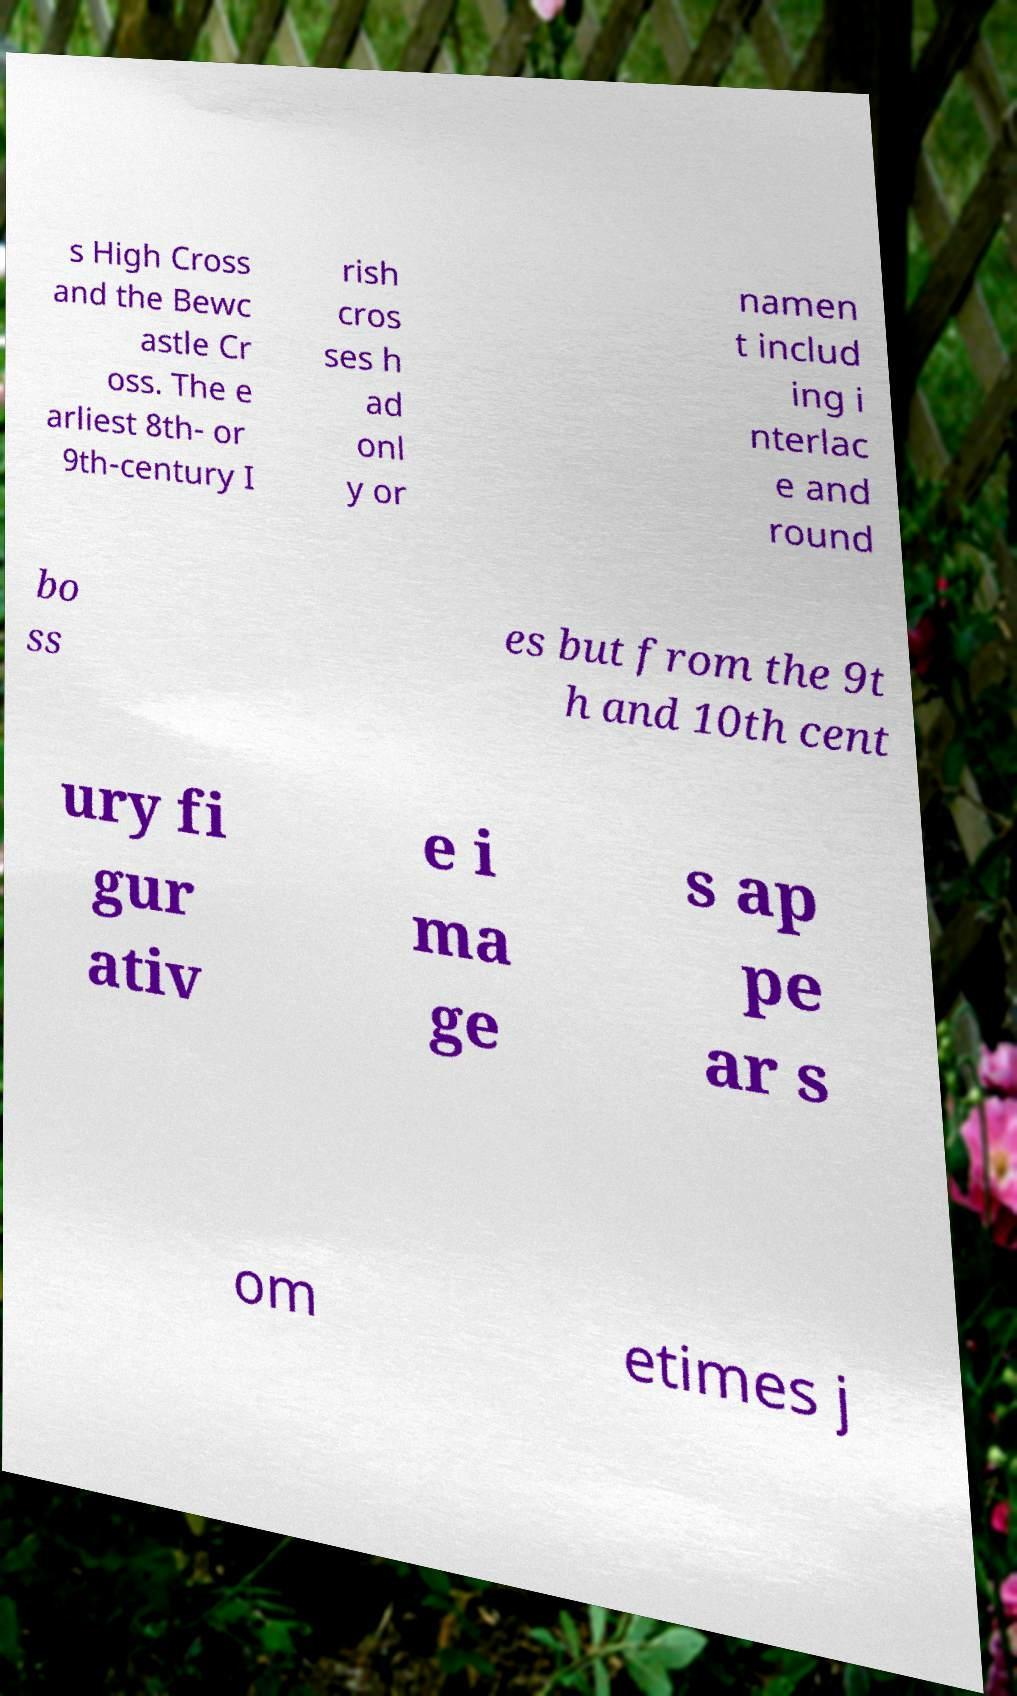Can you accurately transcribe the text from the provided image for me? s High Cross and the Bewc astle Cr oss. The e arliest 8th- or 9th-century I rish cros ses h ad onl y or namen t includ ing i nterlac e and round bo ss es but from the 9t h and 10th cent ury fi gur ativ e i ma ge s ap pe ar s om etimes j 